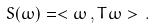<formula> <loc_0><loc_0><loc_500><loc_500>S ( \omega ) = < \omega \, , T \omega > \, .</formula> 